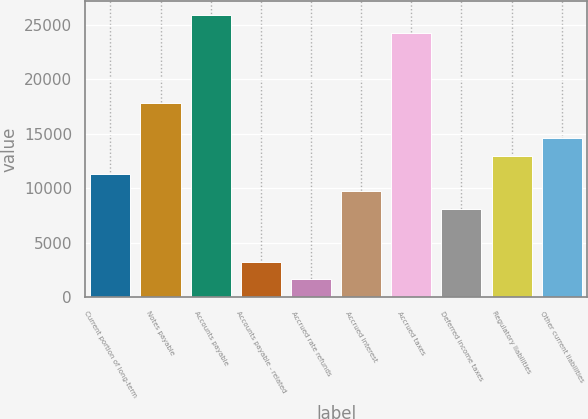<chart> <loc_0><loc_0><loc_500><loc_500><bar_chart><fcel>Current portion of long-term<fcel>Notes payable<fcel>Accounts payable<fcel>Accounts payable - related<fcel>Accrued rate refunds<fcel>Accrued interest<fcel>Accrued taxes<fcel>Deferred income taxes<fcel>Regulatory liabilities<fcel>Other current liabilities<nl><fcel>11325.9<fcel>17796.7<fcel>25885.2<fcel>3237.4<fcel>1619.7<fcel>9708.2<fcel>24267.5<fcel>8090.5<fcel>12943.6<fcel>14561.3<nl></chart> 